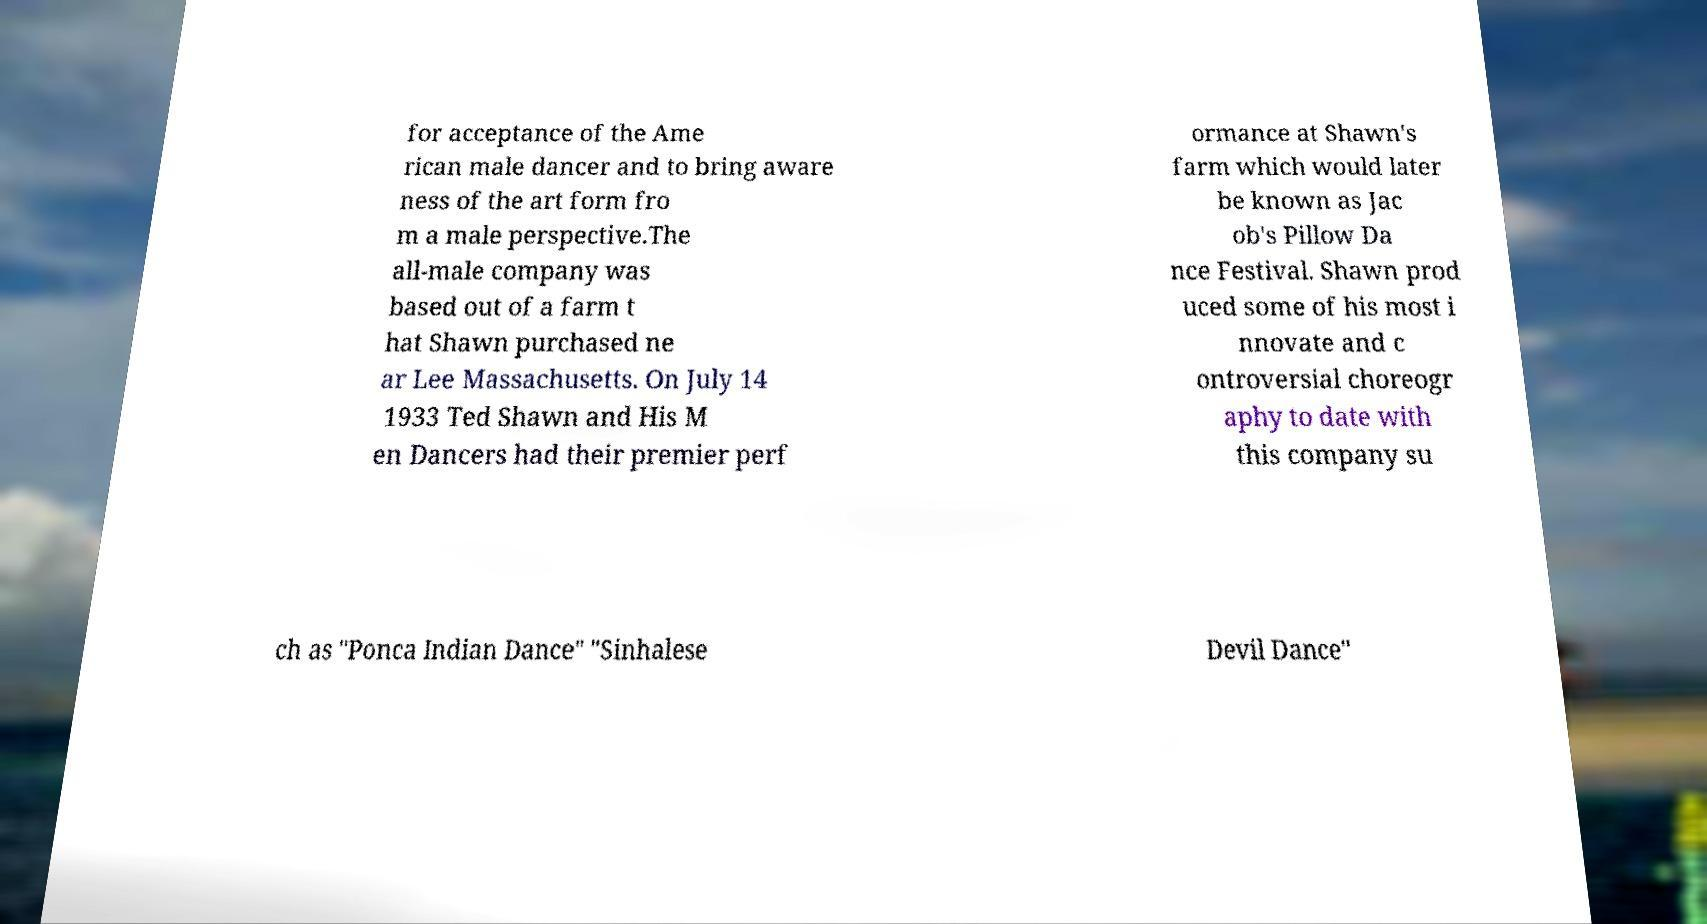For documentation purposes, I need the text within this image transcribed. Could you provide that? for acceptance of the Ame rican male dancer and to bring aware ness of the art form fro m a male perspective.The all-male company was based out of a farm t hat Shawn purchased ne ar Lee Massachusetts. On July 14 1933 Ted Shawn and His M en Dancers had their premier perf ormance at Shawn's farm which would later be known as Jac ob's Pillow Da nce Festival. Shawn prod uced some of his most i nnovate and c ontroversial choreogr aphy to date with this company su ch as "Ponca Indian Dance" "Sinhalese Devil Dance" 